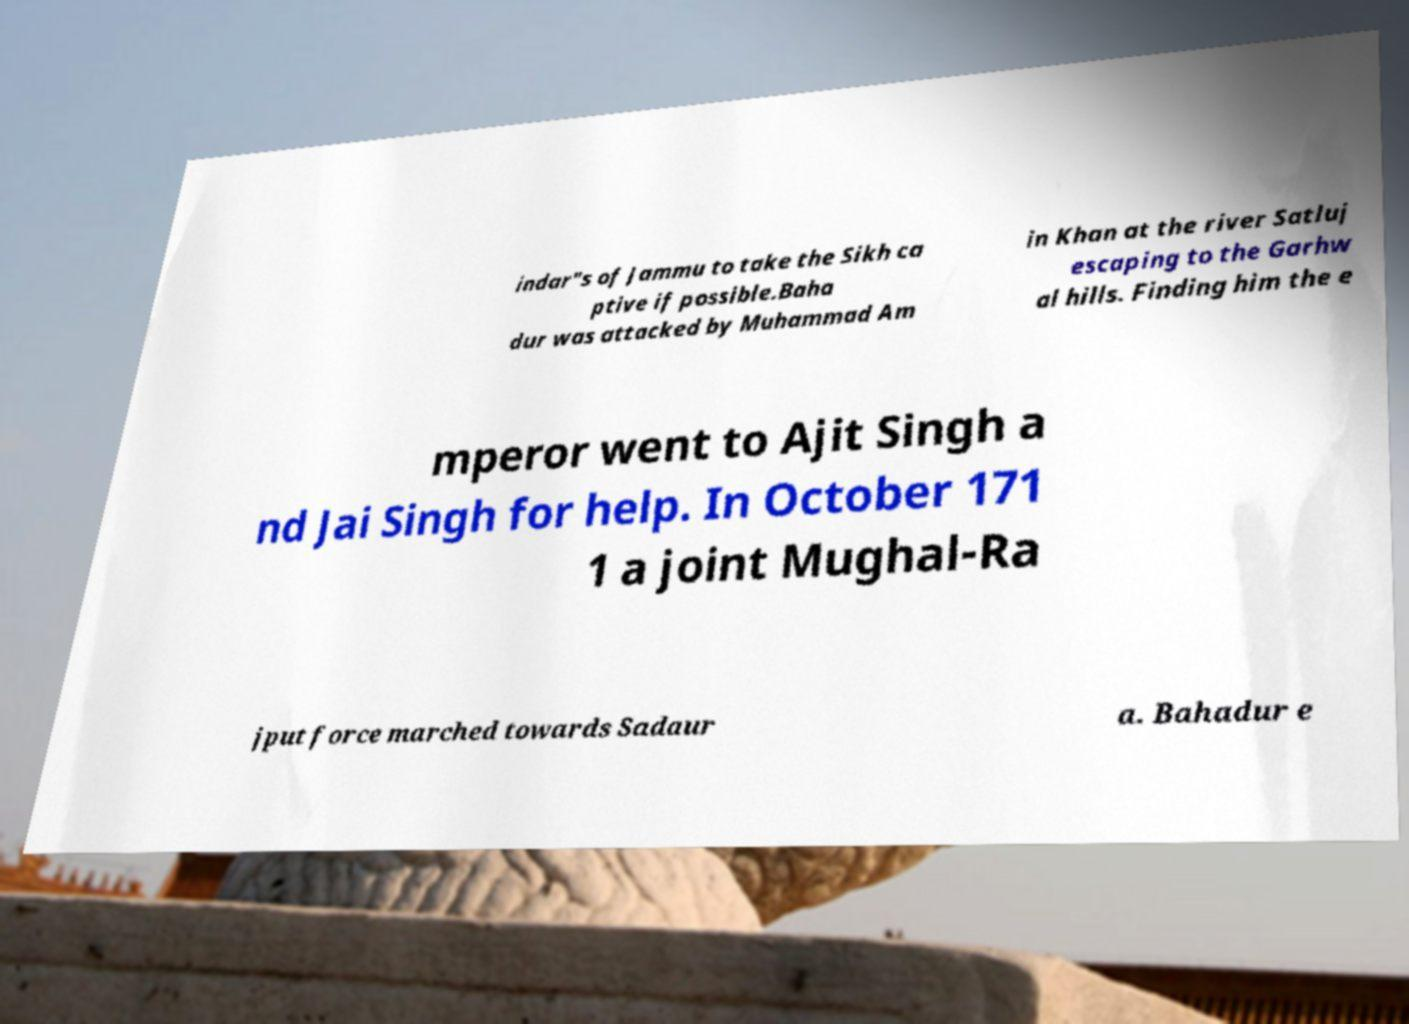There's text embedded in this image that I need extracted. Can you transcribe it verbatim? indar"s of Jammu to take the Sikh ca ptive if possible.Baha dur was attacked by Muhammad Am in Khan at the river Satluj escaping to the Garhw al hills. Finding him the e mperor went to Ajit Singh a nd Jai Singh for help. In October 171 1 a joint Mughal-Ra jput force marched towards Sadaur a. Bahadur e 